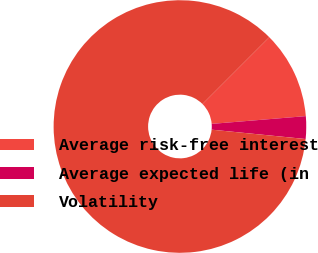Convert chart. <chart><loc_0><loc_0><loc_500><loc_500><pie_chart><fcel>Average risk-free interest<fcel>Average expected life (in<fcel>Volatility<nl><fcel>11.19%<fcel>2.89%<fcel>85.91%<nl></chart> 